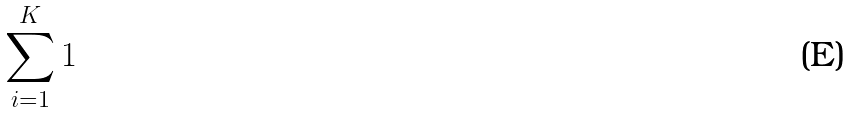<formula> <loc_0><loc_0><loc_500><loc_500>\sum _ { i = 1 } ^ { K } 1</formula> 